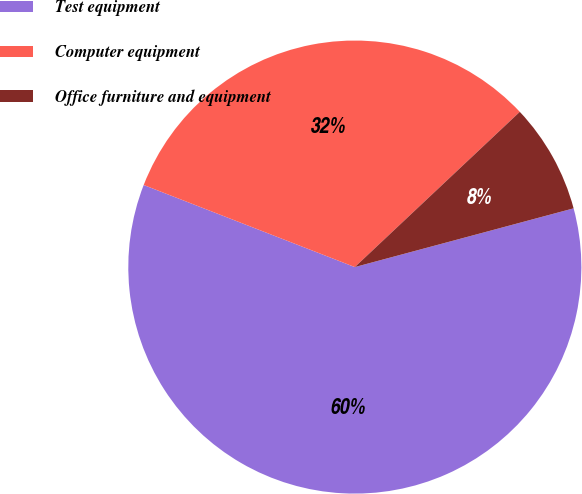Convert chart. <chart><loc_0><loc_0><loc_500><loc_500><pie_chart><fcel>Test equipment<fcel>Computer equipment<fcel>Office furniture and equipment<nl><fcel>60.07%<fcel>32.08%<fcel>7.84%<nl></chart> 